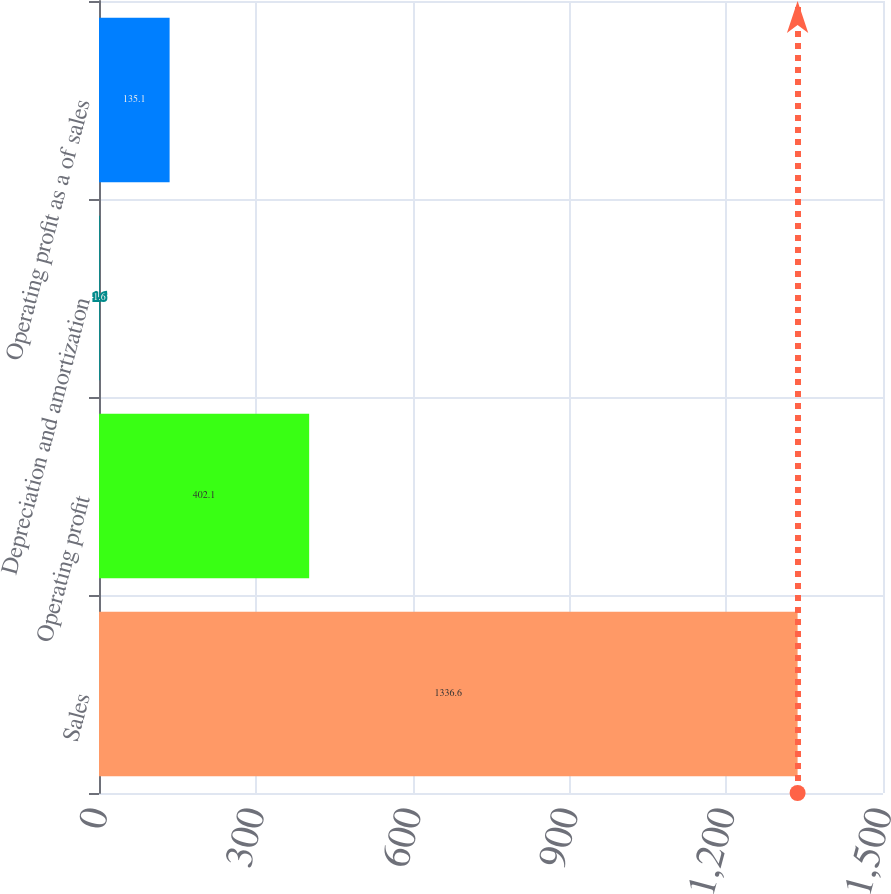Convert chart to OTSL. <chart><loc_0><loc_0><loc_500><loc_500><bar_chart><fcel>Sales<fcel>Operating profit<fcel>Depreciation and amortization<fcel>Operating profit as a of sales<nl><fcel>1336.6<fcel>402.1<fcel>1.6<fcel>135.1<nl></chart> 